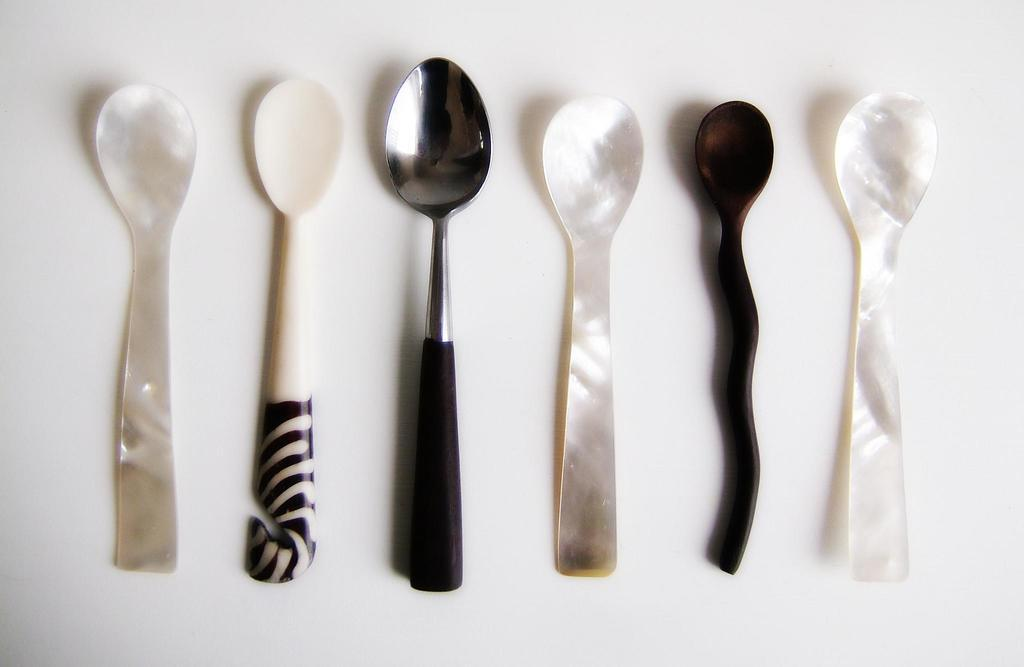What objects are present in the image? There are different types of spoons in the image. How many spoons can be seen in the image? There are six spoons in the image. Where are the spoons located? The spoons are placed on a table. What is the color of the background in the image? The background of the image is white. What type of statement can be seen written on the spoons in the image? There are no statements written on the spoons in the image; they are just different types of spoons placed on a table. 